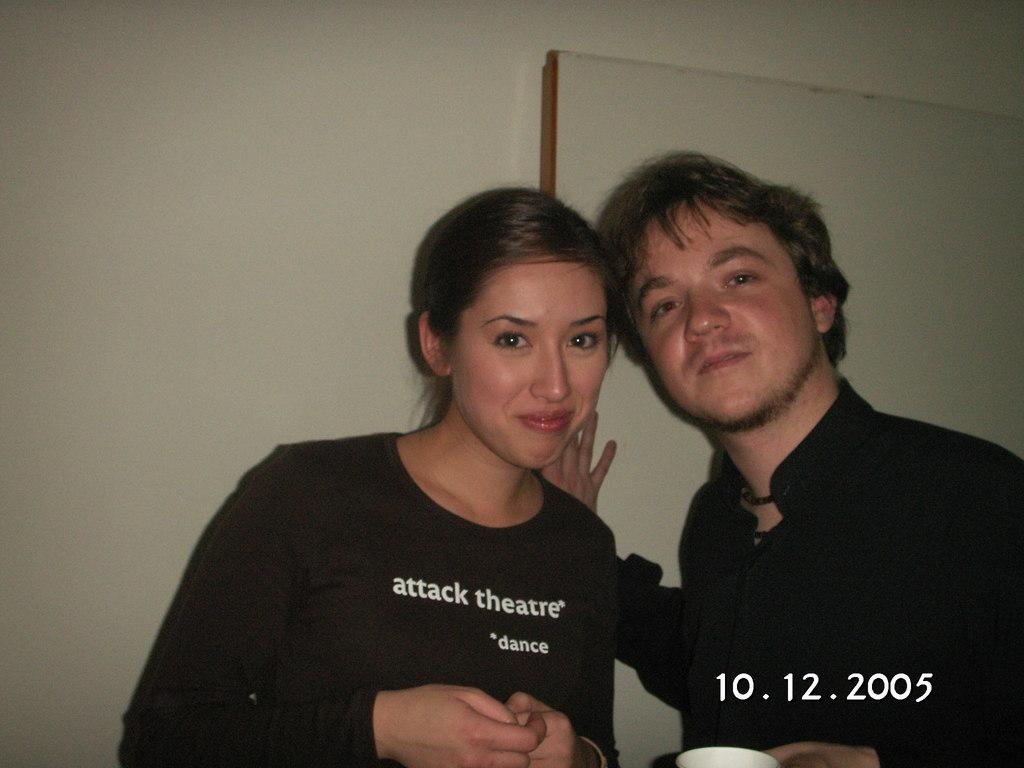How many people are in the image? There are two people in the image. What color are the dresses worn by the people in the image? Both people are wearing black color dresses. What is the color of the background in the image? The background of the image is white. What type of flower can be seen growing in the yard in the image? There is no yard or flower present in the image; it features two people wearing black dresses against a white background. 